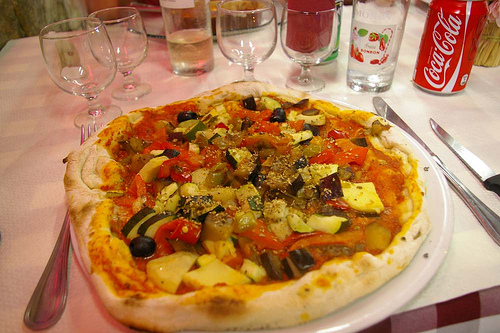What is the color of the pepper to the right of the vegetable? The pepper to the right of the vegetable boasts a vibrant yellow hue, standing out amidst the other vibrant veggies. 